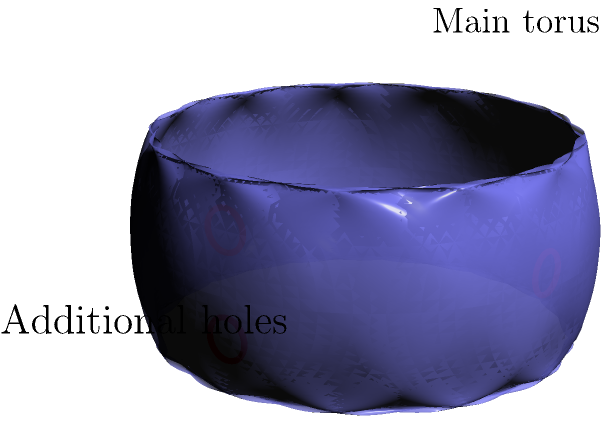In the context of topology, consider a torus with three additional holes as shown in the figure. What is the genus of this modified torus? Recall that the genus of a surface is the number of handles or "holes" it has. To determine the genus of this modified torus, we need to follow these steps:

1. Recall that a standard torus (without additional holes) has a genus of 1.

2. Count the additional holes:
   - There are two holes on the surface of the torus (red circles on the blue surface)
   - There is one hole going through the torus perpendicular to its central hole (red circle on the right)

3. Calculate the total genus:
   - Start with the genus of the standard torus: 1
   - Add the number of additional holes: 3
   - Total genus = $1 + 3 = 4$

4. Interpretation:
   Each hole contributes to the genus of the surface. The original torus hole plus the three additional holes result in a surface with four "handles" or ways to pass through it.

5. Topological equivalence:
   This modified torus is topologically equivalent to a sphere with four handles, which is the definition of a genus-4 surface.

Therefore, the genus of this modified torus is 4.
Answer: 4 